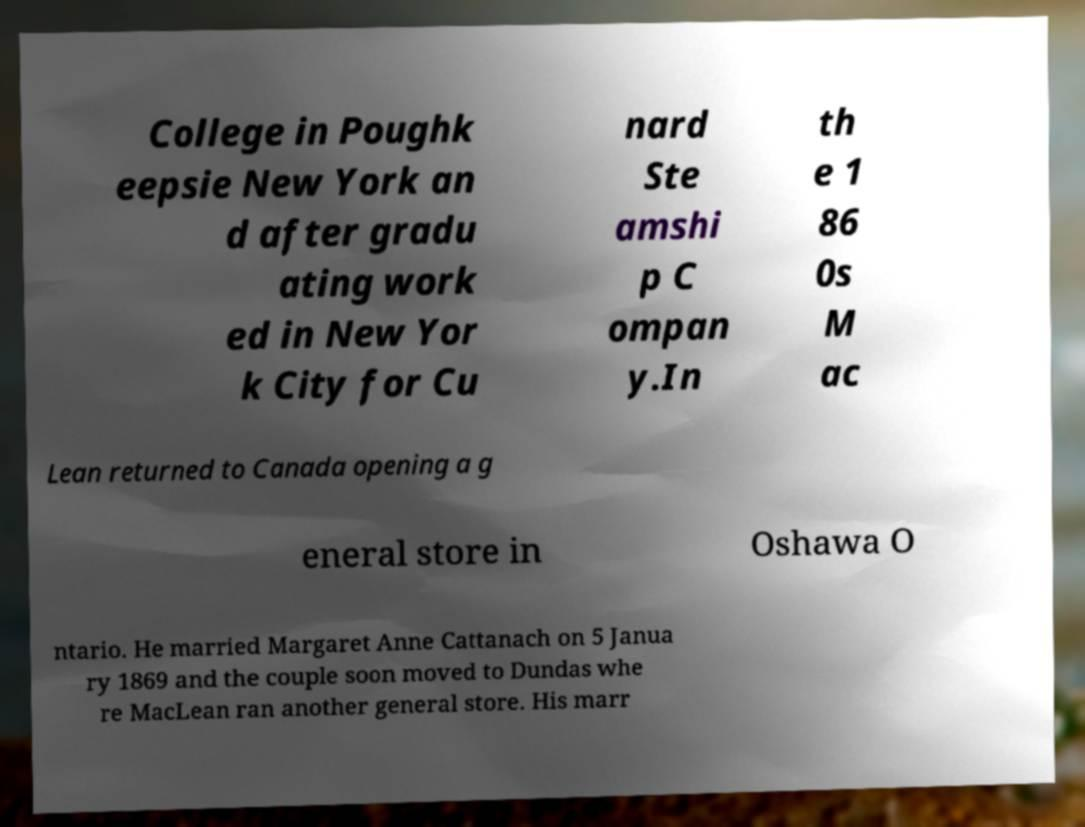Can you read and provide the text displayed in the image?This photo seems to have some interesting text. Can you extract and type it out for me? College in Poughk eepsie New York an d after gradu ating work ed in New Yor k City for Cu nard Ste amshi p C ompan y.In th e 1 86 0s M ac Lean returned to Canada opening a g eneral store in Oshawa O ntario. He married Margaret Anne Cattanach on 5 Janua ry 1869 and the couple soon moved to Dundas whe re MacLean ran another general store. His marr 